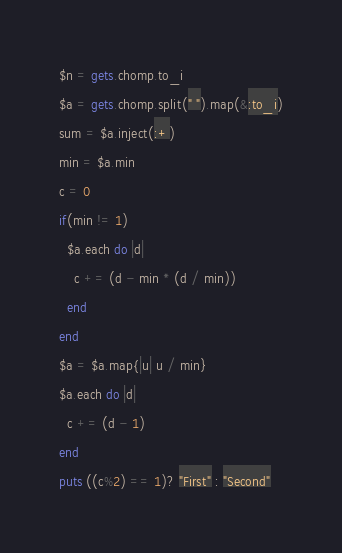<code> <loc_0><loc_0><loc_500><loc_500><_Ruby_>$n = gets.chomp.to_i
$a = gets.chomp.split(" ").map(&:to_i)
sum = $a.inject(:+)
min = $a.min
c = 0
if(min != 1)
  $a.each do |d|
    c += (d - min * (d / min))
  end
end
$a = $a.map{|u| u / min}
$a.each do |d|
  c += (d - 1)
end
puts ((c%2) == 1)? "First" : "Second"</code> 